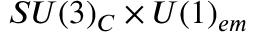<formula> <loc_0><loc_0><loc_500><loc_500>S U ( 3 ) _ { C } \times U ( 1 ) _ { e m }</formula> 